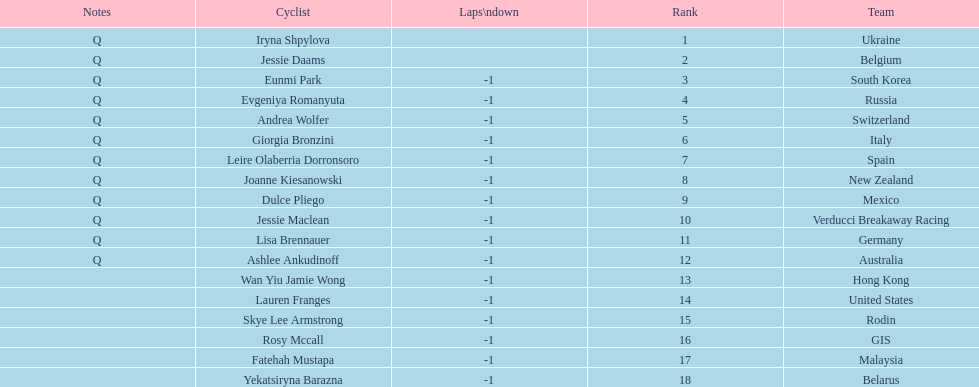How many consecutive notes are there? 12. 